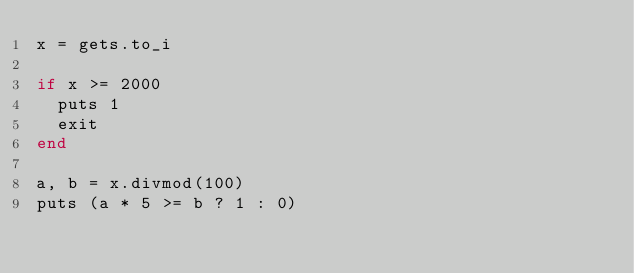<code> <loc_0><loc_0><loc_500><loc_500><_Ruby_>x = gets.to_i

if x >= 2000
  puts 1
  exit
end

a, b = x.divmod(100)
puts (a * 5 >= b ? 1 : 0)
</code> 